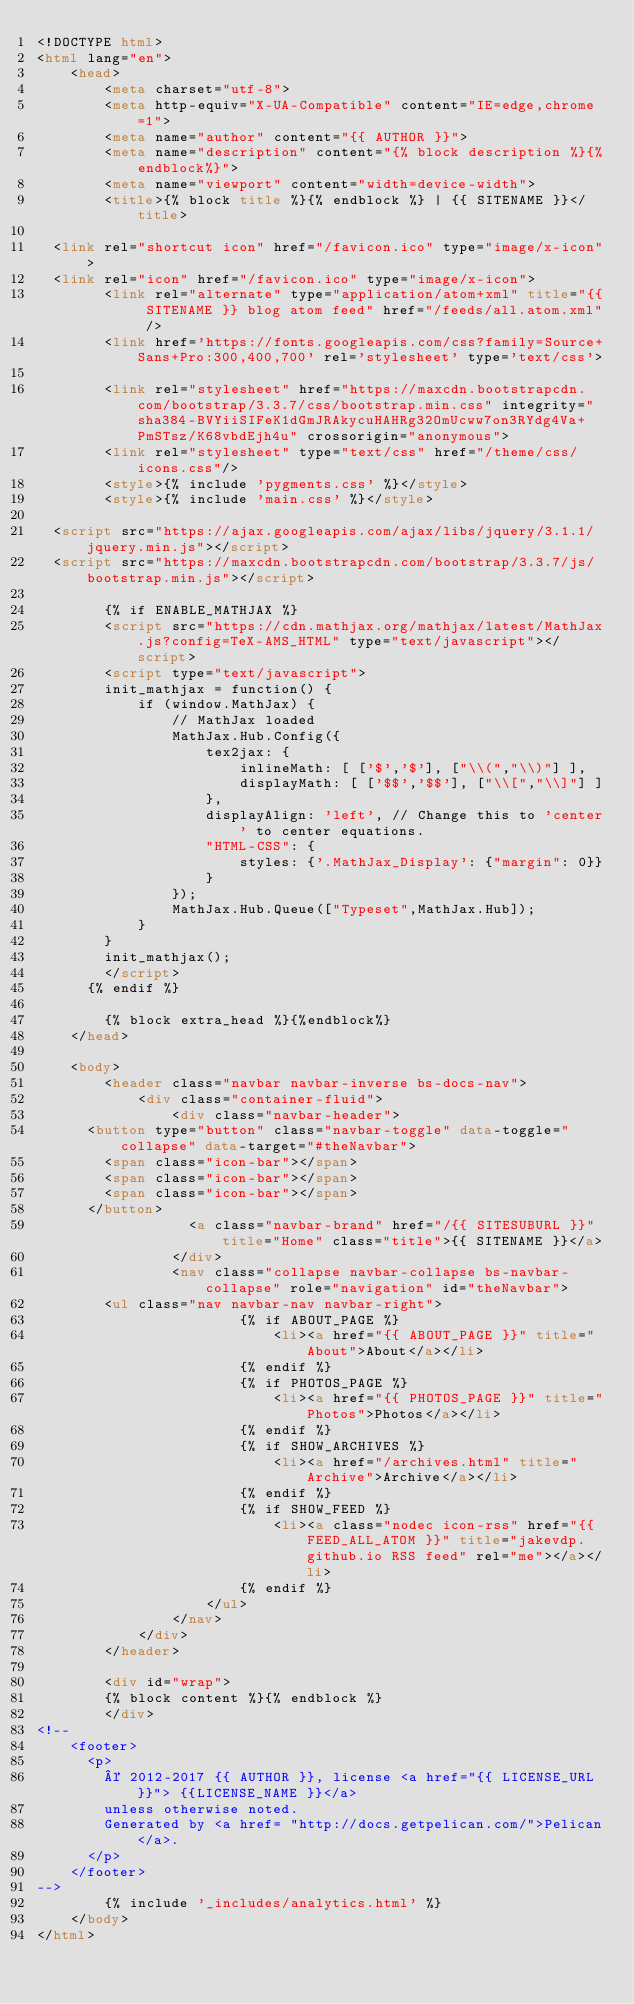Convert code to text. <code><loc_0><loc_0><loc_500><loc_500><_HTML_><!DOCTYPE html>
<html lang="en">
    <head>
        <meta charset="utf-8">
        <meta http-equiv="X-UA-Compatible" content="IE=edge,chrome=1">
        <meta name="author" content="{{ AUTHOR }}">
        <meta name="description" content="{% block description %}{%endblock%}">
        <meta name="viewport" content="width=device-width">
        <title>{% block title %}{% endblock %} | {{ SITENAME }}</title>

	<link rel="shortcut icon" href="/favicon.ico" type="image/x-icon">
	<link rel="icon" href="/favicon.ico" type="image/x-icon">
        <link rel="alternate" type="application/atom+xml" title="{{ SITENAME }} blog atom feed" href="/feeds/all.atom.xml" />
        <link href='https://fonts.googleapis.com/css?family=Source+Sans+Pro:300,400,700' rel='stylesheet' type='text/css'>

        <link rel="stylesheet" href="https://maxcdn.bootstrapcdn.com/bootstrap/3.3.7/css/bootstrap.min.css" integrity="sha384-BVYiiSIFeK1dGmJRAkycuHAHRg32OmUcww7on3RYdg4Va+PmSTsz/K68vbdEjh4u" crossorigin="anonymous">
        <link rel="stylesheet" type="text/css" href="/theme/css/icons.css"/>
        <style>{% include 'pygments.css' %}</style>
        <style>{% include 'main.css' %}</style>

	<script src="https://ajax.googleapis.com/ajax/libs/jquery/3.1.1/jquery.min.js"></script>
	<script src="https://maxcdn.bootstrapcdn.com/bootstrap/3.3.7/js/bootstrap.min.js"></script>

        {% if ENABLE_MATHJAX %}
        <script src="https://cdn.mathjax.org/mathjax/latest/MathJax.js?config=TeX-AMS_HTML" type="text/javascript"></script>
        <script type="text/javascript">
        init_mathjax = function() {
            if (window.MathJax) {
                // MathJax loaded
                MathJax.Hub.Config({
                    tex2jax: {
                        inlineMath: [ ['$','$'], ["\\(","\\)"] ],
                        displayMath: [ ['$$','$$'], ["\\[","\\]"] ]
                    },
                    displayAlign: 'left', // Change this to 'center' to center equations.
                    "HTML-CSS": {
                        styles: {'.MathJax_Display': {"margin": 0}}
                    }
                });
                MathJax.Hub.Queue(["Typeset",MathJax.Hub]);
            }
        }
        init_mathjax();
        </script>
    	{% endif %}

        {% block extra_head %}{%endblock%}
    </head>

    <body>
        <header class="navbar navbar-inverse bs-docs-nav">
            <div class="container-fluid">
                <div class="navbar-header">
		  <button type="button" class="navbar-toggle" data-toggle="collapse" data-target="#theNavbar">
		    <span class="icon-bar"></span>
		    <span class="icon-bar"></span>
		    <span class="icon-bar"></span> 
		  </button>
                  <a class="navbar-brand" href="/{{ SITESUBURL }}" title="Home" class="title">{{ SITENAME }}</a>
                </div>
                <nav class="collapse navbar-collapse bs-navbar-collapse" role="navigation" id="theNavbar">
		    <ul class="nav navbar-nav navbar-right">
                        {% if ABOUT_PAGE %}
                            <li><a href="{{ ABOUT_PAGE }}" title="About">About</a></li>
                        {% endif %}
                        {% if PHOTOS_PAGE %}
                            <li><a href="{{ PHOTOS_PAGE }}" title="Photos">Photos</a></li>
                        {% endif %}
                        {% if SHOW_ARCHIVES %}
                            <li><a href="/archives.html" title="Archive">Archive</a></li>
                        {% endif %}
                        {% if SHOW_FEED %}
                            <li><a class="nodec icon-rss" href="{{ FEED_ALL_ATOM }}" title="jakevdp.github.io RSS feed" rel="me"></a></li>
                        {% endif %}
                    </ul>
                </nav>
            </div>
        </header>

        <div id="wrap">
        {% block content %}{% endblock %}
        </div>
<!--
    <footer>
      <p>
        © 2012-2017 {{ AUTHOR }}, license <a href="{{ LICENSE_URL}}"> {{LICENSE_NAME }}</a>
        unless otherwise noted.
        Generated by <a href= "http://docs.getpelican.com/">Pelican</a>.
      </p>
    </footer>
-->
        {% include '_includes/analytics.html' %}
    </body>
</html>
</code> 